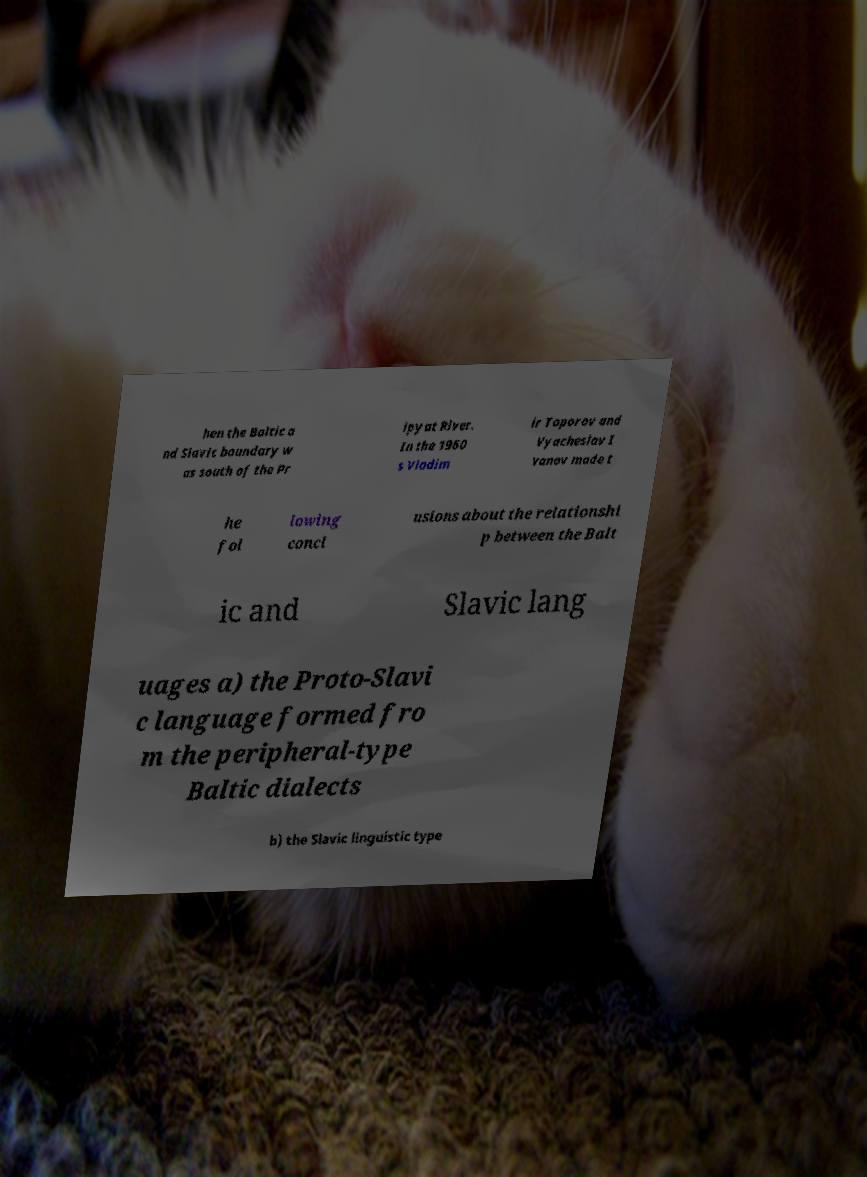Can you read and provide the text displayed in the image?This photo seems to have some interesting text. Can you extract and type it out for me? hen the Baltic a nd Slavic boundary w as south of the Pr ipyat River. In the 1960 s Vladim ir Toporov and Vyacheslav I vanov made t he fol lowing concl usions about the relationshi p between the Balt ic and Slavic lang uages a) the Proto-Slavi c language formed fro m the peripheral-type Baltic dialects b) the Slavic linguistic type 